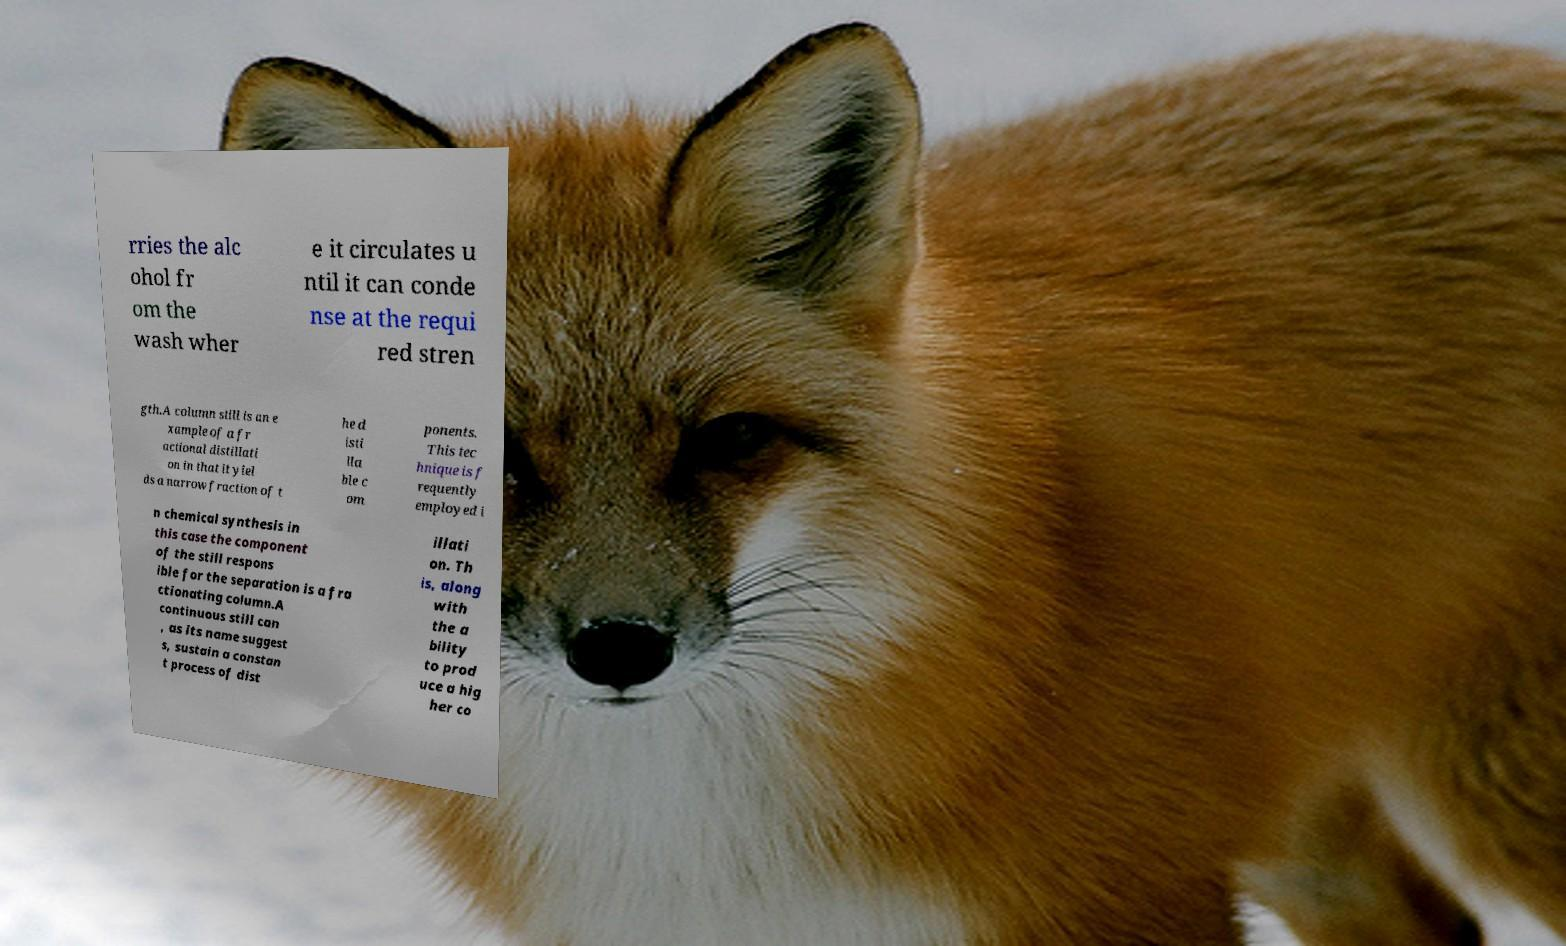Could you assist in decoding the text presented in this image and type it out clearly? rries the alc ohol fr om the wash wher e it circulates u ntil it can conde nse at the requi red stren gth.A column still is an e xample of a fr actional distillati on in that it yiel ds a narrow fraction of t he d isti lla ble c om ponents. This tec hnique is f requently employed i n chemical synthesis in this case the component of the still respons ible for the separation is a fra ctionating column.A continuous still can , as its name suggest s, sustain a constan t process of dist illati on. Th is, along with the a bility to prod uce a hig her co 